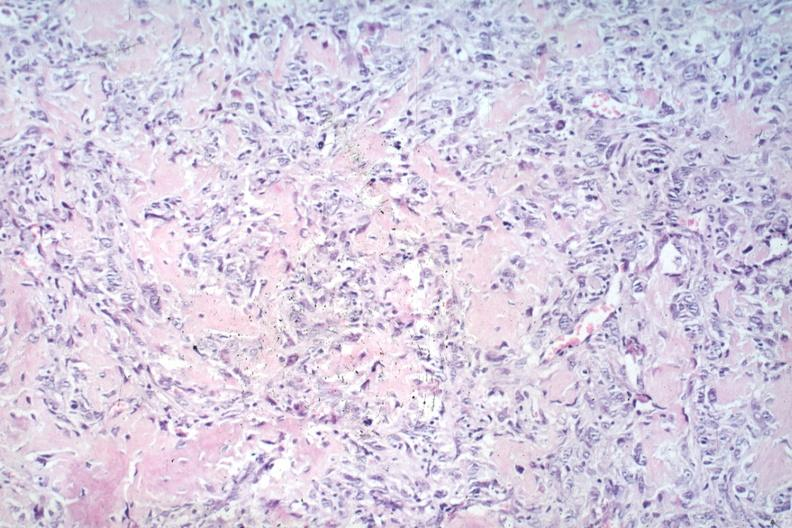s wrights single cell present?
Answer the question using a single word or phrase. No 